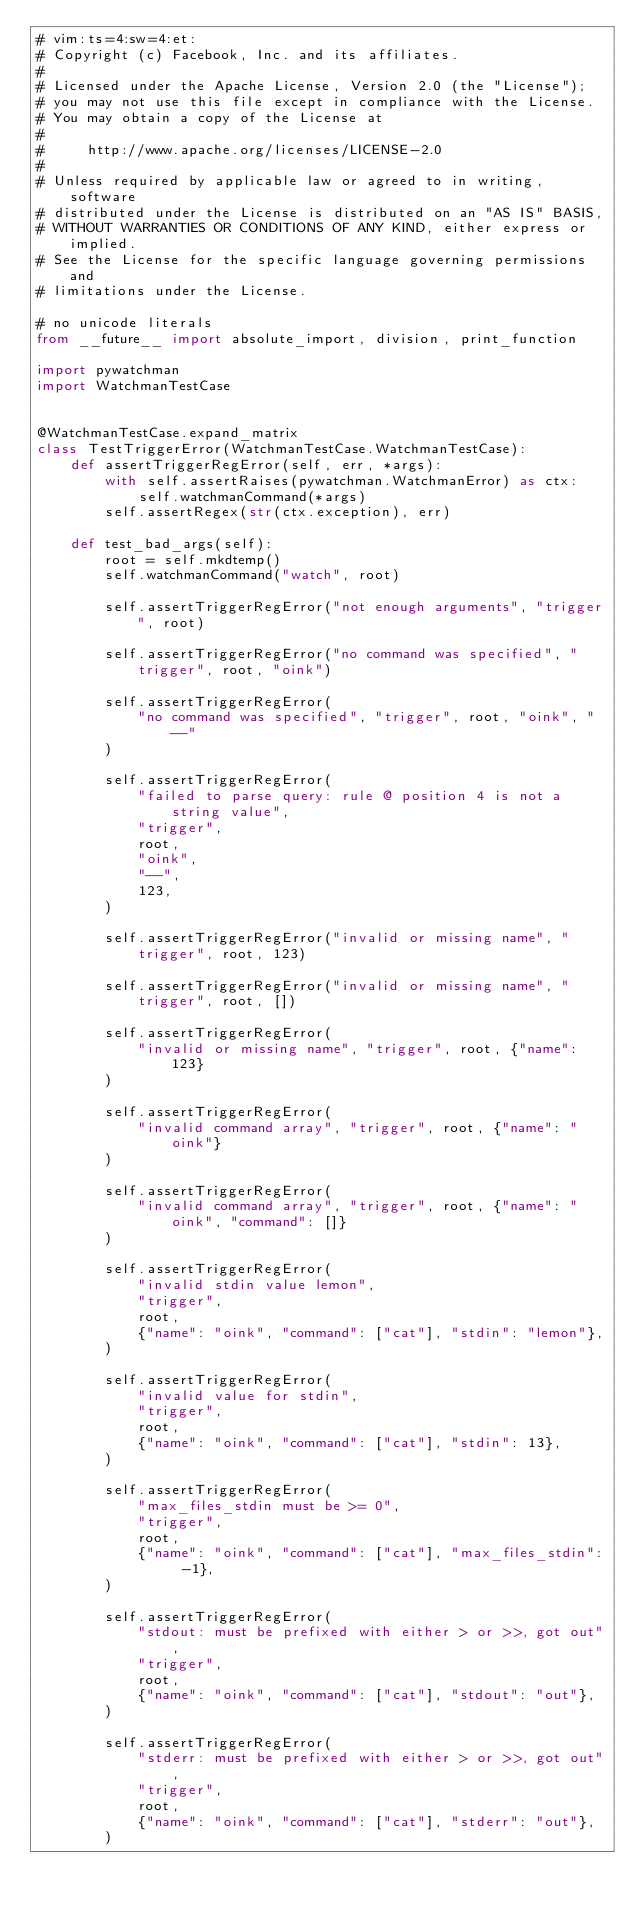Convert code to text. <code><loc_0><loc_0><loc_500><loc_500><_Python_># vim:ts=4:sw=4:et:
# Copyright (c) Facebook, Inc. and its affiliates.
#
# Licensed under the Apache License, Version 2.0 (the "License");
# you may not use this file except in compliance with the License.
# You may obtain a copy of the License at
#
#     http://www.apache.org/licenses/LICENSE-2.0
#
# Unless required by applicable law or agreed to in writing, software
# distributed under the License is distributed on an "AS IS" BASIS,
# WITHOUT WARRANTIES OR CONDITIONS OF ANY KIND, either express or implied.
# See the License for the specific language governing permissions and
# limitations under the License.

# no unicode literals
from __future__ import absolute_import, division, print_function

import pywatchman
import WatchmanTestCase


@WatchmanTestCase.expand_matrix
class TestTriggerError(WatchmanTestCase.WatchmanTestCase):
    def assertTriggerRegError(self, err, *args):
        with self.assertRaises(pywatchman.WatchmanError) as ctx:
            self.watchmanCommand(*args)
        self.assertRegex(str(ctx.exception), err)

    def test_bad_args(self):
        root = self.mkdtemp()
        self.watchmanCommand("watch", root)

        self.assertTriggerRegError("not enough arguments", "trigger", root)

        self.assertTriggerRegError("no command was specified", "trigger", root, "oink")

        self.assertTriggerRegError(
            "no command was specified", "trigger", root, "oink", "--"
        )

        self.assertTriggerRegError(
            "failed to parse query: rule @ position 4 is not a string value",
            "trigger",
            root,
            "oink",
            "--",
            123,
        )

        self.assertTriggerRegError("invalid or missing name", "trigger", root, 123)

        self.assertTriggerRegError("invalid or missing name", "trigger", root, [])

        self.assertTriggerRegError(
            "invalid or missing name", "trigger", root, {"name": 123}
        )

        self.assertTriggerRegError(
            "invalid command array", "trigger", root, {"name": "oink"}
        )

        self.assertTriggerRegError(
            "invalid command array", "trigger", root, {"name": "oink", "command": []}
        )

        self.assertTriggerRegError(
            "invalid stdin value lemon",
            "trigger",
            root,
            {"name": "oink", "command": ["cat"], "stdin": "lemon"},
        )

        self.assertTriggerRegError(
            "invalid value for stdin",
            "trigger",
            root,
            {"name": "oink", "command": ["cat"], "stdin": 13},
        )

        self.assertTriggerRegError(
            "max_files_stdin must be >= 0",
            "trigger",
            root,
            {"name": "oink", "command": ["cat"], "max_files_stdin": -1},
        )

        self.assertTriggerRegError(
            "stdout: must be prefixed with either > or >>, got out",
            "trigger",
            root,
            {"name": "oink", "command": ["cat"], "stdout": "out"},
        )

        self.assertTriggerRegError(
            "stderr: must be prefixed with either > or >>, got out",
            "trigger",
            root,
            {"name": "oink", "command": ["cat"], "stderr": "out"},
        )
</code> 